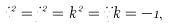Convert formula to latex. <formula><loc_0><loc_0><loc_500><loc_500>i ^ { 2 } = j ^ { 2 } = k ^ { 2 } = i j k = - 1 ,</formula> 